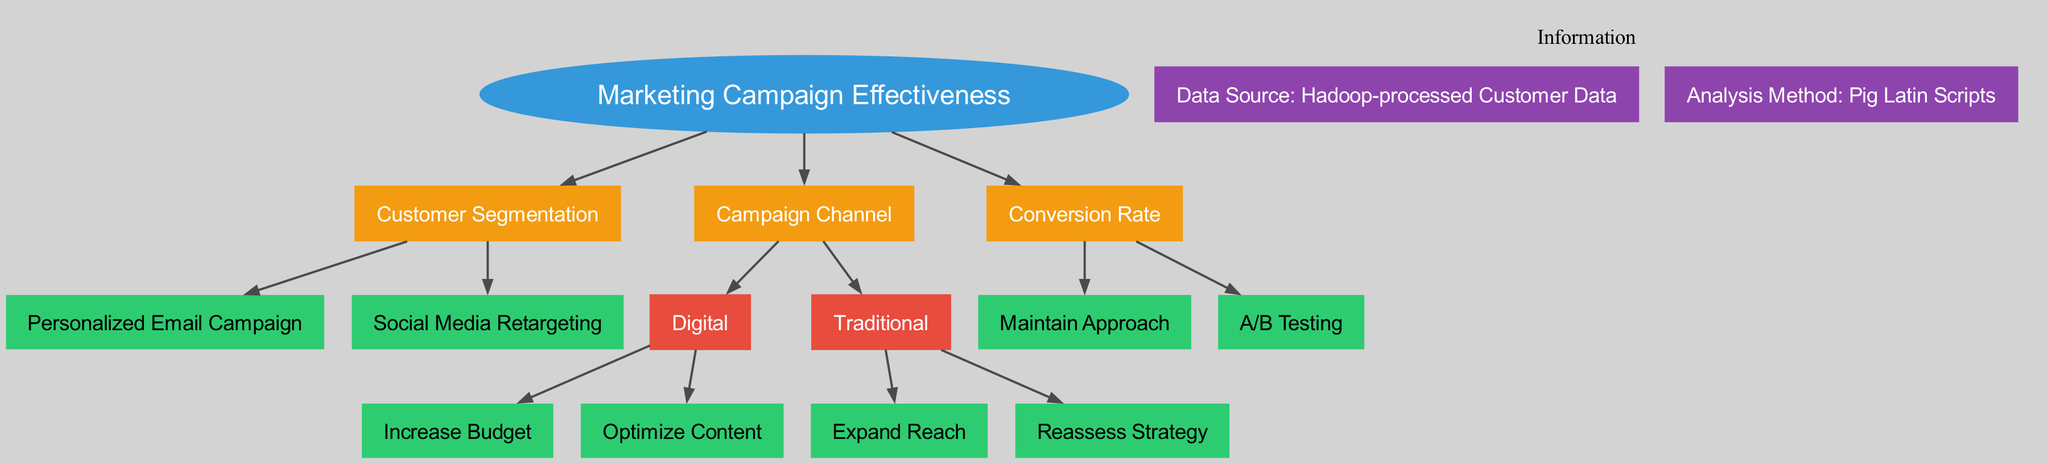What is the root node of the decision tree? The diagram specifies "Marketing Campaign Effectiveness" as the root node, which is the starting point for decision-making pathways regarding campaign strategies.
Answer: Marketing Campaign Effectiveness How many branches does the root node have? There are three branches extending from the root node, representing different aspects influencing marketing campaign effectiveness: Customer Segmentation, Campaign Channel, and Conversion Rate.
Answer: 3 What action is recommended for High-value Customers? The diagram indicates that the leaf node for High-value Customers is "Personalized Email Campaign," which is the recommended action based on this segmentation.
Answer: Personalized Email Campaign What should be done if the Click-through Rate is greater than 2% in a Digital campaign? The diagram shows that if the Click-through Rate exceeds 2%, the recommendation is to "Increase Budget," indicating a positive response to campaign performance.
Answer: Increase Budget If the ROI for a Traditional campaign is less than 150%, what is the suggested action? According to the diagram, the action to take if the ROI is below 150% is to "Reassess Strategy," highlighting the need for evaluation and adjustment in this scenario.
Answer: Reassess Strategy What is recommended if the Conversion Rate is less than 5%? The diagram suggests conducting "A/B Testing" if the Conversion Rate falls below 5%, allowing for experimentation to improve performance.
Answer: A/B Testing How does the decision tree classify Occasional Buyers? The node structure shows that Occasional Buyers lead to the leaf node "Social Media Retargeting," categorizing them under a specific marketing approach.
Answer: Social Media Retargeting What are the two possible recommendations based on the Campaign Channel? For the Campaign Channel, the two branches are Digital, which leads to increasing the budget or optimizing content, and Traditional, which results in expanding reach or reassessing strategy, making four possible recommendations.
Answer: Four recommendations What is the purpose of using Hadoop-processed Customer Data in this model? The diagram explicitly states that "Hadoop-processed Customer Data" is the data source for the decision tree analysis, implying it plays a vital role in evaluating the effectiveness of marketing campaigns.
Answer: Data Source: Hadoop-processed Customer Data 